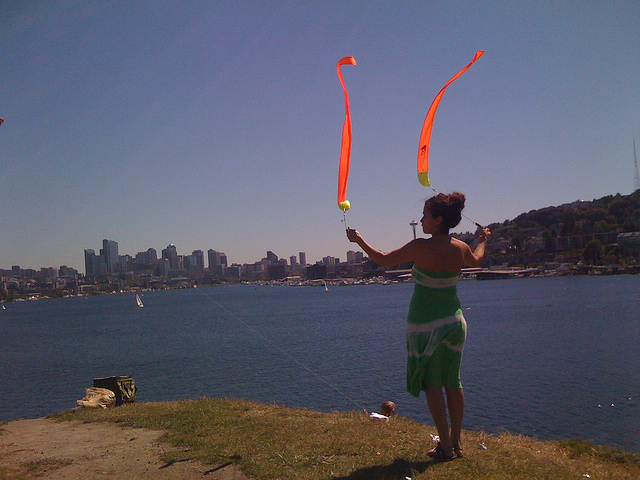<image>What color is the woman's shoes? I am not sure about the color of the woman's shoes. It could be black, brown, or red. What color is the woman's shoes? I don't know what color is the woman's shoes. It can be black, brown, red or even no shoes. 